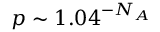Convert formula to latex. <formula><loc_0><loc_0><loc_500><loc_500>p \sim 1 . 0 4 ^ { - N _ { A } }</formula> 